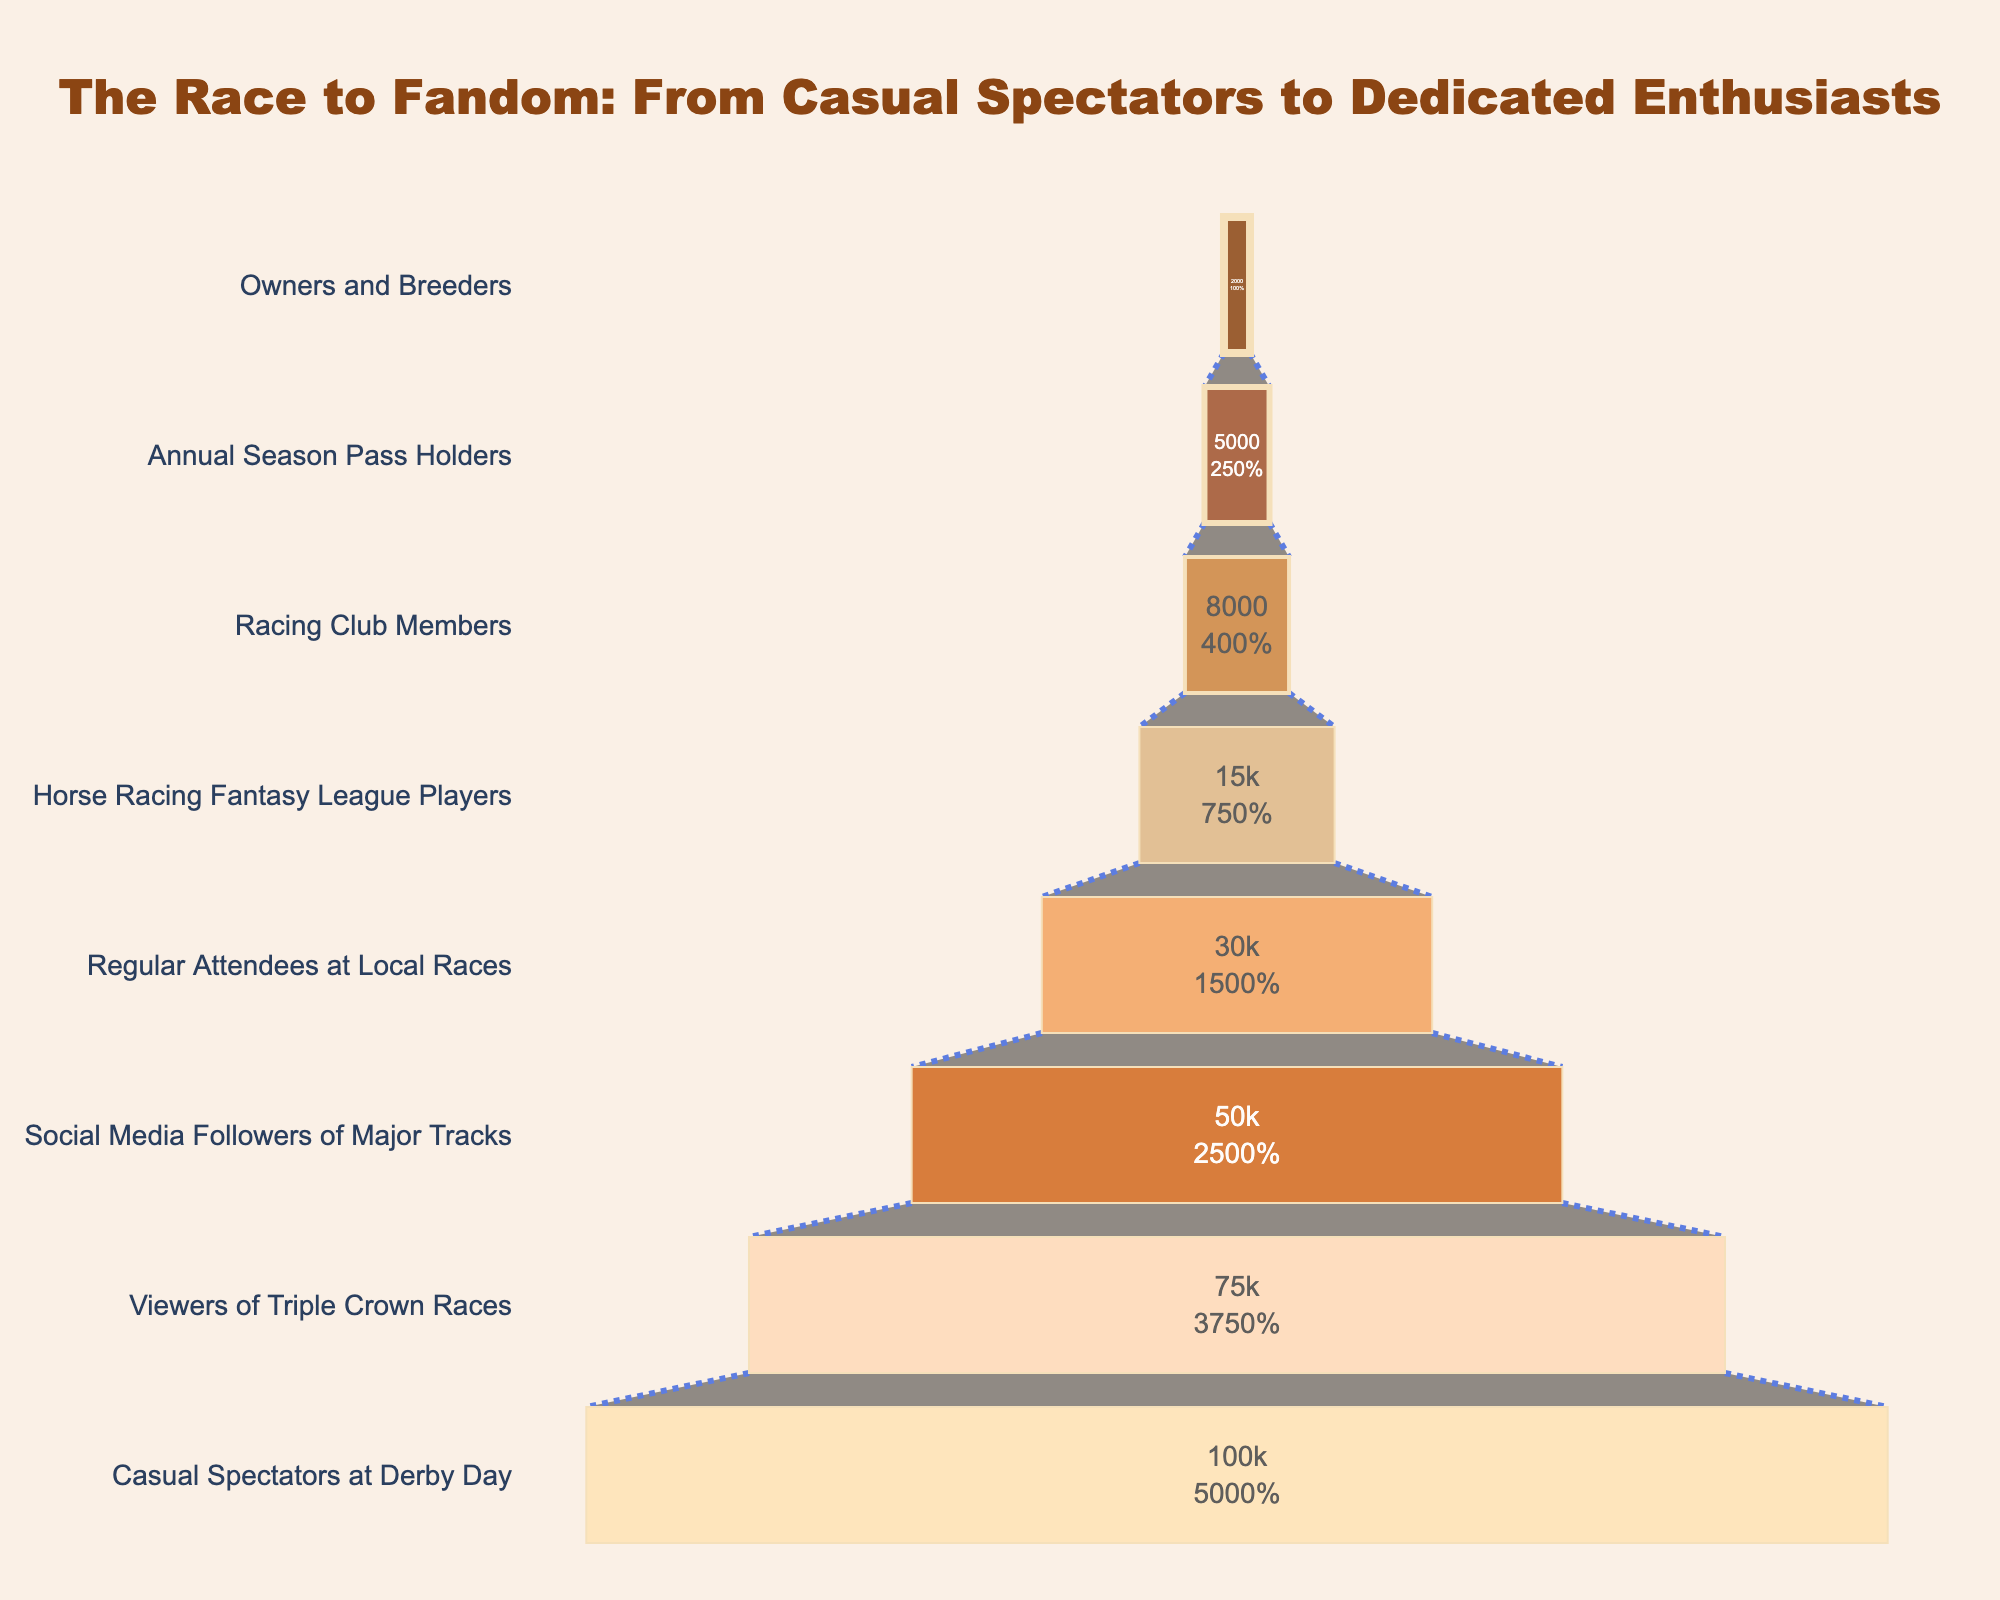What's the title of the chart? The title of the chart is displayed at the top center of the figure. It indicates the main focus of the chart: converting casual spectators to dedicated horse racing enthusiasts.
Answer: The Race to Fandom: From Casual Spectators to Dedicated Enthusiasts How many stages are represented in the funnel chart? To determine the number of stages, count the distinct levels listed on the y-axis of the funnel chart.
Answer: 8 What is the number of Horse Racing Fantasy League Players? Locate the specific stage labeled "Horse Racing Fantasy League Players" and read the corresponding number of people from the x-axis or inside the funnel segment.
Answer: 15,000 Identify the stage with the least number of people. Examine the values listed for each stage in the funnel chart, focusing on the smallest number.
Answer: Owners and Breeders What percentage of the initial casual spectators become regular attendees at local races? Find the value for "Regular Attendees at Local Races" (30,000) and the initial "Casual Spectators at Derby Day" (100,000). Calculate the percentage by dividing 30,000 by 100,000 and multiplying by 100.
Answer: 30% How many more viewers are there for Triple Crown Races compared to Owners and Breeders? Locate the numbers for "Viewers of Triple Crown Races" (75,000) and "Owners and Breeders" (2,000). Subtract the latter from the former: 75,000 - 2,000.
Answer: 73,000 What stage comes immediately after "Social Media Followers of Major Tracks"? Look at the stage sequence on the y-axis. Identify the stage that follows "Social Media Followers of Major Tracks".
Answer: Regular Attendees at Local Races Which stage shows the highest drop in numbers compared to its preceding stage? Compare the numerical difference between adjacent stages. Identify the pair with the largest drop. The largest drop can be found between "Casual Spectators at Derby Day" (100,000) and "Viewers of Triple Crown Races" (75,000).
Answer: Viewers of Triple Crown Races What is the total number of people at the bottom three stages? Identify and sum the numbers from "Racing Club Members" (8,000), "Annual Season Pass Holders" (5,000), and "Owners and Breeders" (2,000). The sum is 8,000 + 5,000 + 2,000.
Answer: 15,000 In what stage are 20% of the initial casual spectators interested? Identify each stage's number of people as a percentage of the initial number (100,000). Find the stage with a number close to 20% of 100,000 (which is 20,000).
Answer: Regular Attendees at Local Races 